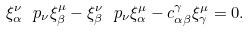Convert formula to latex. <formula><loc_0><loc_0><loc_500><loc_500>\xi ^ { \nu } _ { \alpha } \ p _ { \nu } \xi ^ { \mu } _ { \beta } - \xi ^ { \nu } _ { \beta } \ p _ { \nu } \xi ^ { \mu } _ { \alpha } - c ^ { \gamma } _ { \alpha \beta } \xi ^ { \mu } _ { \gamma } = 0 .</formula> 